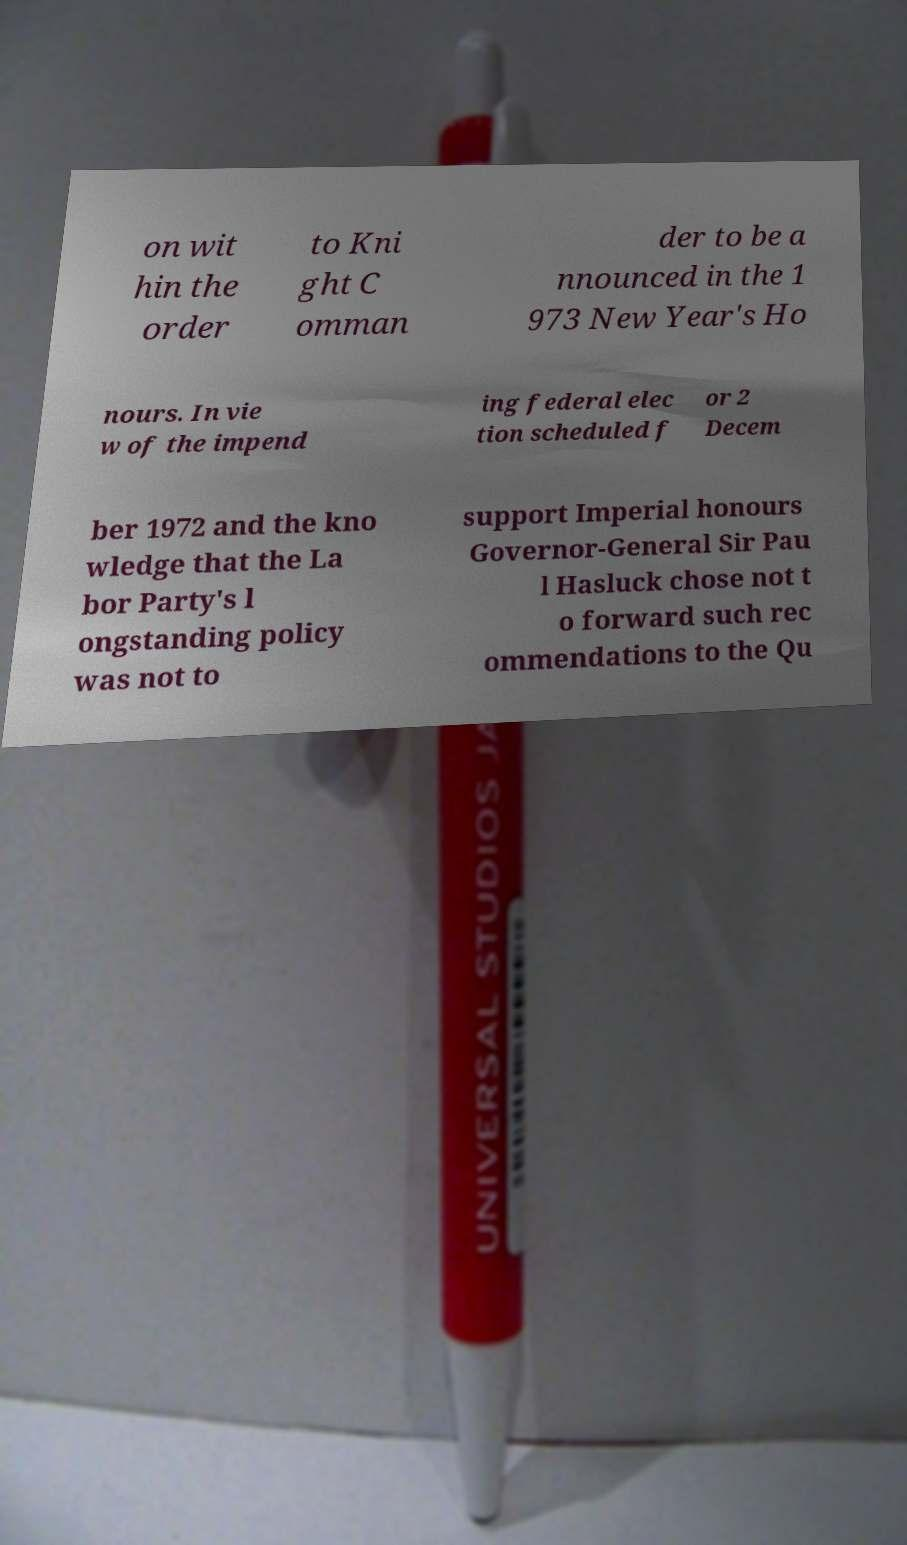Please read and relay the text visible in this image. What does it say? on wit hin the order to Kni ght C omman der to be a nnounced in the 1 973 New Year's Ho nours. In vie w of the impend ing federal elec tion scheduled f or 2 Decem ber 1972 and the kno wledge that the La bor Party's l ongstanding policy was not to support Imperial honours Governor-General Sir Pau l Hasluck chose not t o forward such rec ommendations to the Qu 